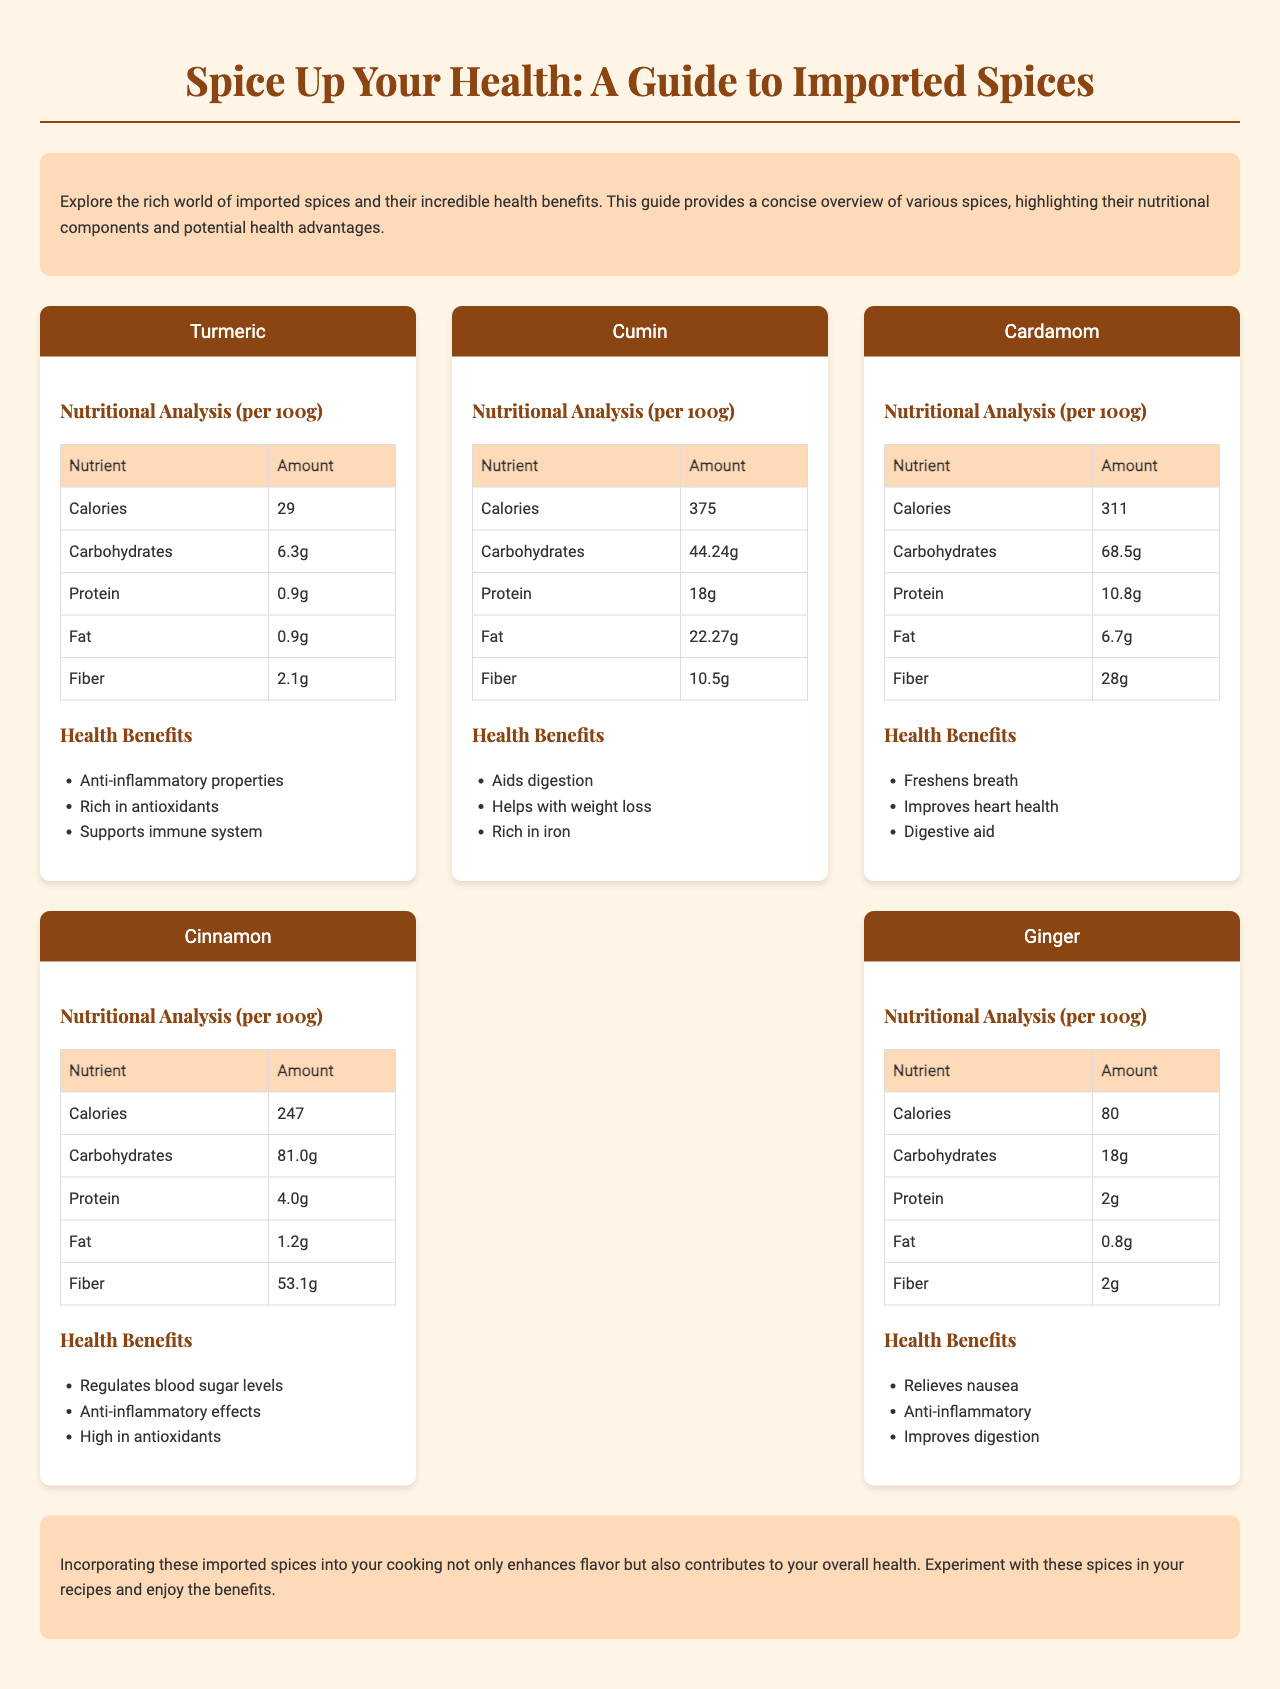What are the health benefits of Turmeric? Turmeric has several health benefits including anti-inflammatory properties, being rich in antioxidants, and supporting the immune system.
Answer: Anti-inflammatory properties, rich in antioxidants, supports immune system What is the amount of fiber in Cinnamon per 100g? The fiber content for Cinnamon is listed in the nutritional analysis table of the document, which shows it as 53.1g per 100g.
Answer: 53.1g How many grams of protein does Cumin contain per 100g? The nutritional analysis section for Cumin provides the protein amount as 18g per 100g.
Answer: 18g Which spice is known for freshening breath? The document lists Cardamom as having freshening breath as one of its health benefits.
Answer: Cardamom What nutrient is highest in Cardamom? The nutritional analysis indicates that the carbohydrate content in Cardamom is 68.5g, which is higher than other nutrients.
Answer: Carbohydrates What is the caloric content of Ginger per 100g? According to the nutritional analysis table in the document, the caloric content of Ginger is 80 calories per 100g.
Answer: 80 What spice helps with weight loss? The document mentions that Cumin aids digestion and helps with weight loss in its health benefits section.
Answer: Cumin How many grams of fat are in Turmeric? The nutritional analysis for Turmeric shows that the fat content is 0.9g per 100g.
Answer: 0.9g 